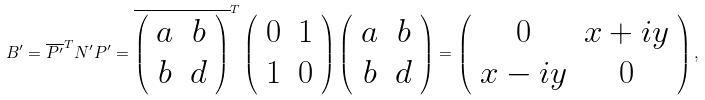<formula> <loc_0><loc_0><loc_500><loc_500>B ^ { \prime } = \overline { P ^ { \prime } } ^ { T } N ^ { \prime } P ^ { \prime } = \overline { \left ( \begin{array} { c c } a & b \\ b & d \end{array} \right ) } ^ { T } \left ( \begin{array} { c c } 0 & 1 \\ 1 & 0 \end{array} \right ) \left ( \begin{array} { c c } a & b \\ b & d \end{array} \right ) = \left ( \begin{array} { c c } 0 & x + i y \\ x - i y & 0 \end{array} \right ) ,</formula> 